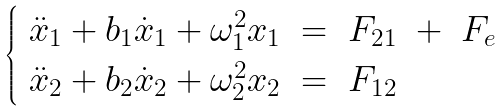Convert formula to latex. <formula><loc_0><loc_0><loc_500><loc_500>\begin{cases} \ \ddot { x } _ { 1 } + b _ { 1 } \dot { x } _ { 1 } + \omega _ { 1 } ^ { 2 } x _ { 1 } \ = \ F _ { 2 1 } \ + \ F _ { e } \\ \ \ddot { x } _ { 2 } + b _ { 2 } \dot { x } _ { 2 } + \omega _ { 2 } ^ { 2 } x _ { 2 } \ = \ F _ { 1 2 } \end{cases}</formula> 